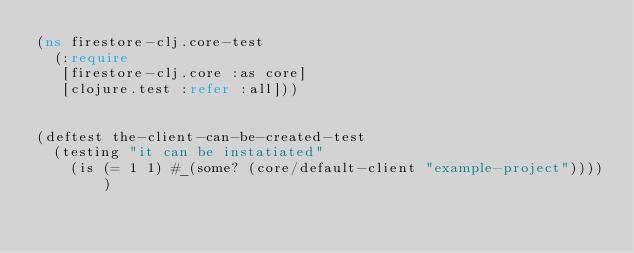Convert code to text. <code><loc_0><loc_0><loc_500><loc_500><_Clojure_>(ns firestore-clj.core-test
  (:require
   [firestore-clj.core :as core]
   [clojure.test :refer :all]))


(deftest the-client-can-be-created-test
  (testing "it can be instatiated"
    (is (= 1 1) #_(some? (core/default-client "example-project")))))
</code> 